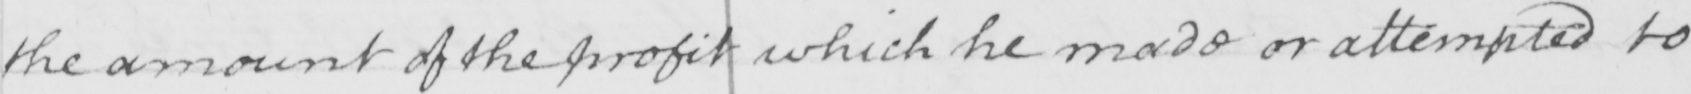Can you tell me what this handwritten text says? the amount of the profit which he made or attempted to 